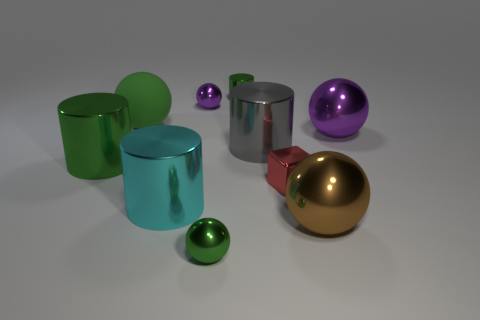How many purple spheres must be subtracted to get 1 purple spheres? 1 Subtract 1 balls. How many balls are left? 4 Subtract all brown spheres. How many spheres are left? 4 Subtract all small purple metal balls. How many balls are left? 4 Subtract all gray spheres. Subtract all cyan cylinders. How many spheres are left? 5 Subtract all cylinders. How many objects are left? 6 Add 5 brown shiny balls. How many brown shiny balls are left? 6 Add 6 cyan shiny things. How many cyan shiny things exist? 7 Subtract 0 purple blocks. How many objects are left? 10 Subtract all large gray rubber cubes. Subtract all big purple balls. How many objects are left? 9 